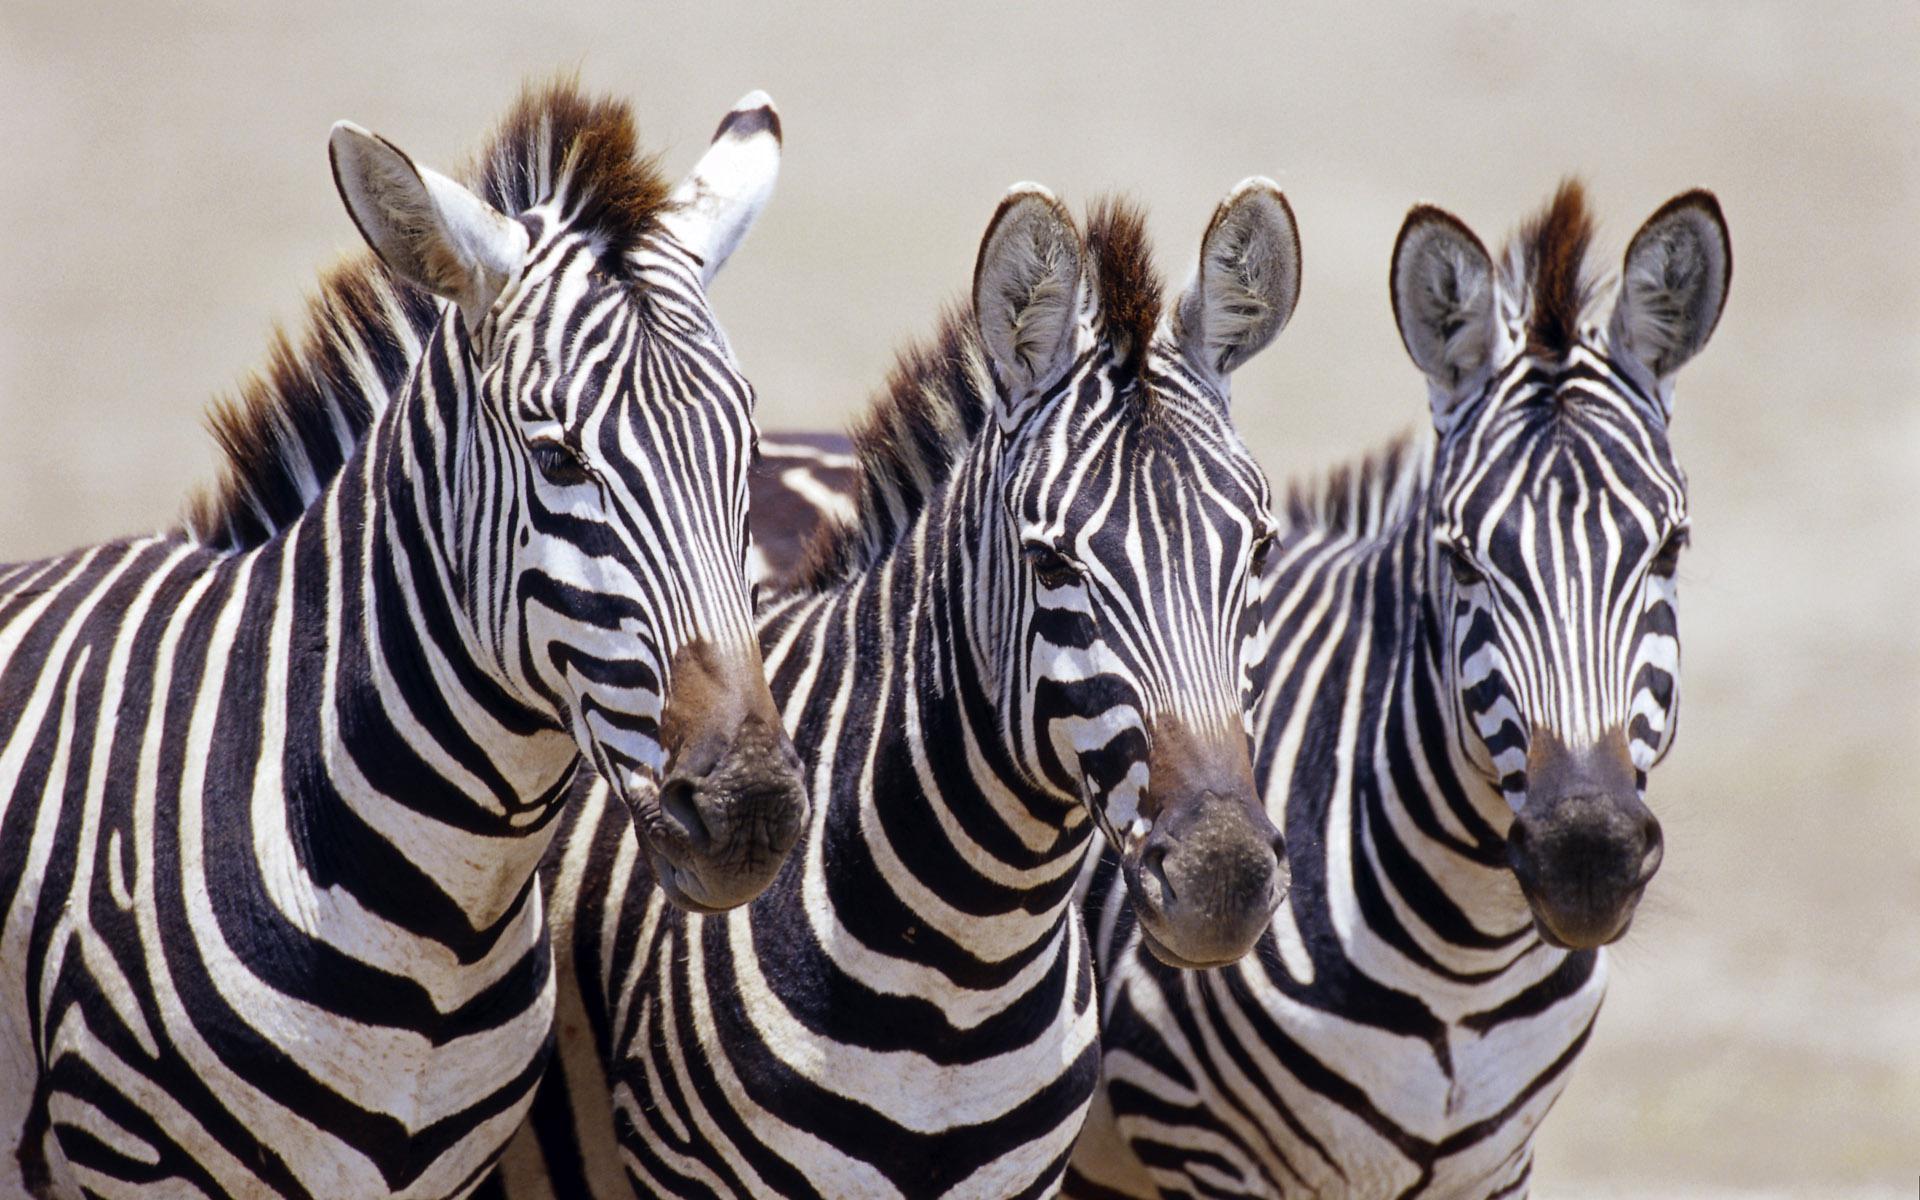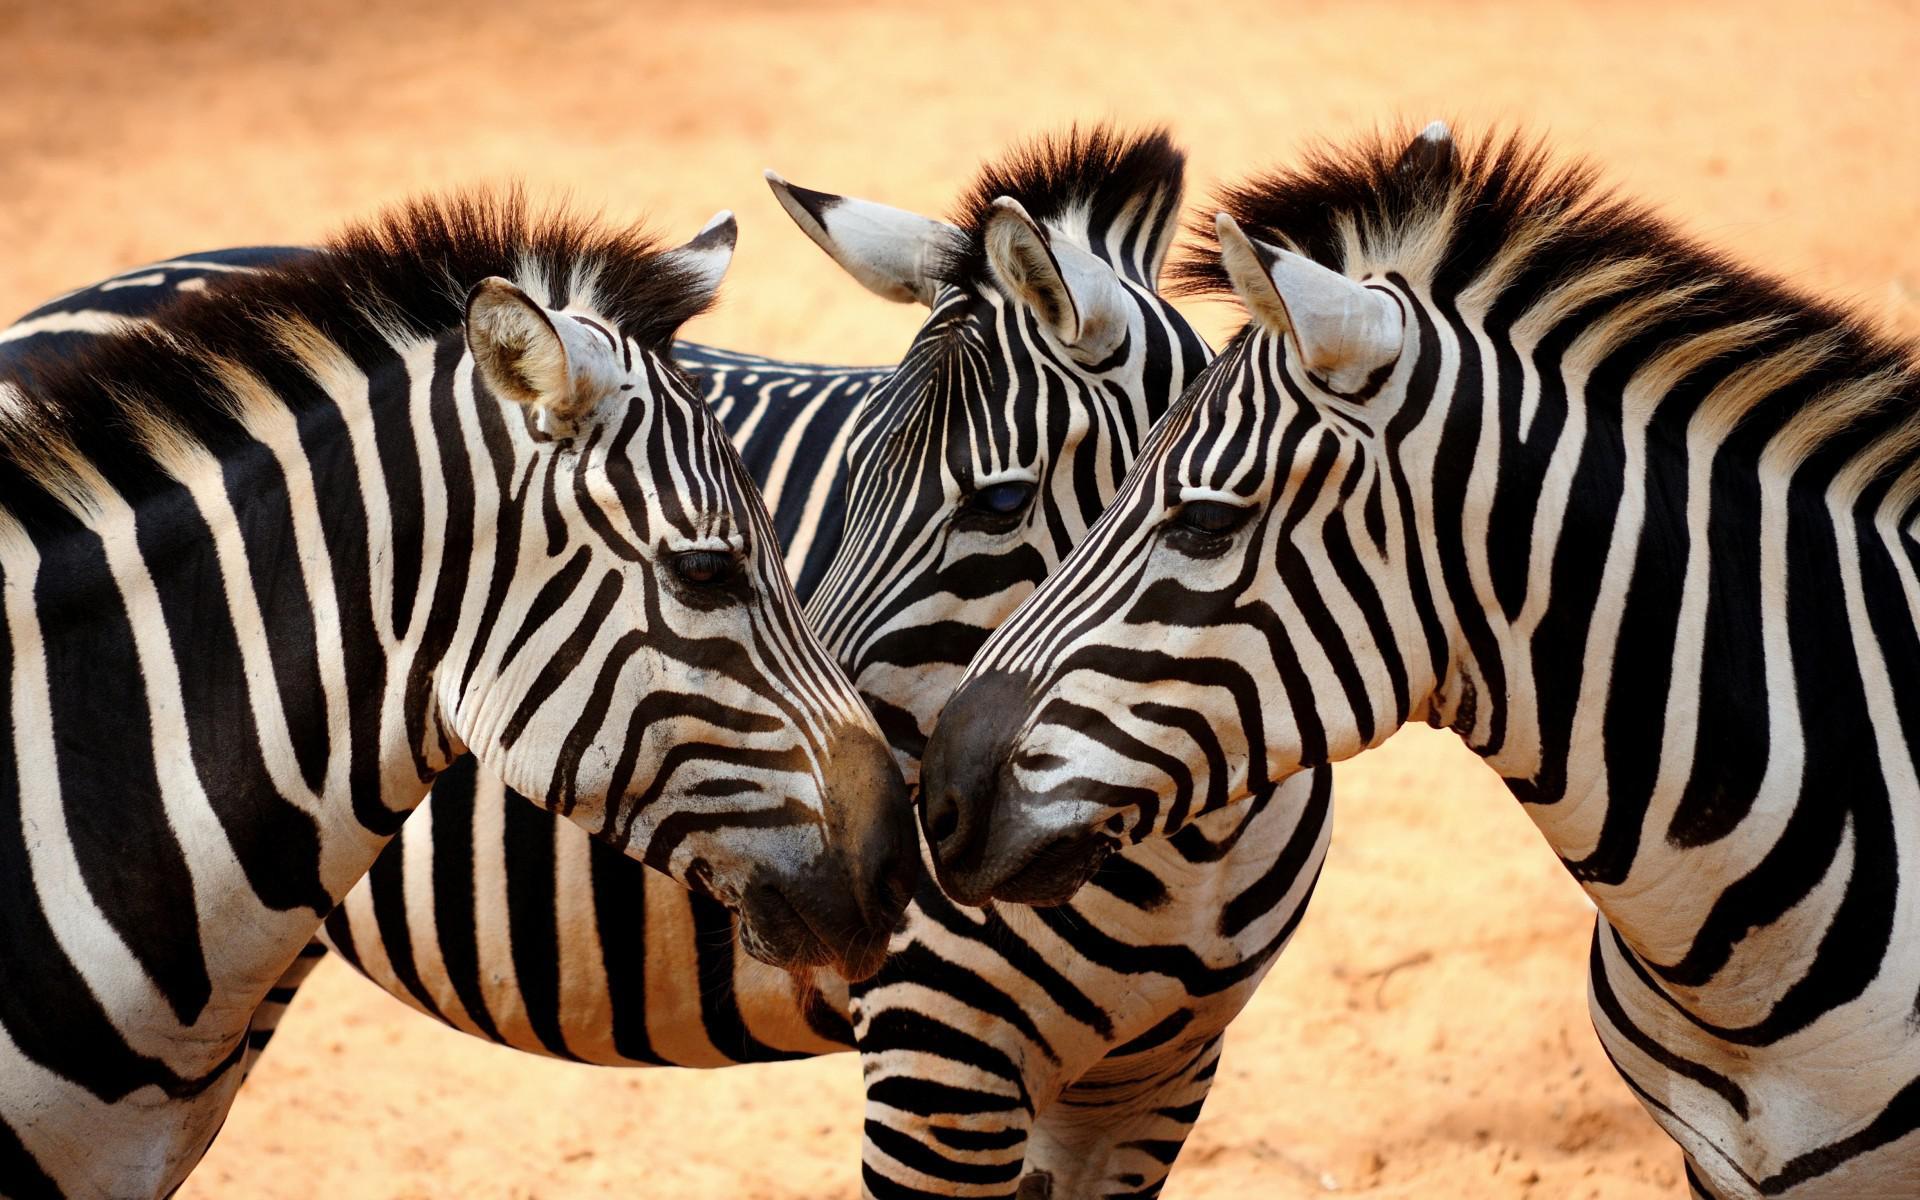The first image is the image on the left, the second image is the image on the right. For the images displayed, is the sentence "Neither image in the pair shows fewer than three zebras." factually correct? Answer yes or no. Yes. 